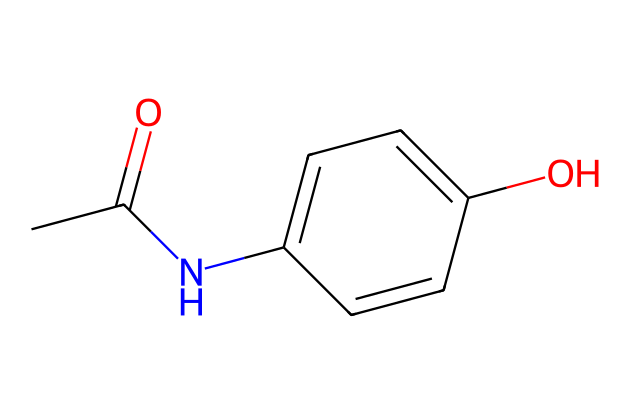What is the common name of this chemical? The SMILES representation corresponds to a chemical structure that is widely recognized as Acetaminophen, which is a commonly used analgesic and antipyretic medication.
Answer: Acetaminophen How many carbon atoms are present in this molecule? By analyzing the SMILES notation, we can count the 'C' characters. There are 8 carbon atoms in total in this structure.
Answer: 8 What functional group is indicated by the 'NC' in the structure? The 'NC' in the SMILES denotes the presence of an amide functional group, where nitrogen (N) is bonded to a carbon (C) atom. This signifies that the molecule contains an amide linkage, indicating it's a drug.
Answer: amide What type of reaction might lead to liver toxicity connected to this drug? Acetaminophen metabolism generates a reactive metabolite that can lead to hepatotoxicity through a process known as bioactivation, especially when taken in excess, contributing to liver damage.
Answer: bioactivation How many rings are there in this molecular structure? The structure contains one aromatic ring indicated by the presence of alternating double bonds around the C1-C6 carbon atoms, characteristic of phenolic compounds.
Answer: 1 What type of bond connects the acetyl group to the aromatic ring? The bond connecting the acetyl group (CC(=O)) to the aromatic ring is a carbon-nitrogen bond from the amide formation, which is a single bond between carbon and nitrogen indicating a covalent linkage.
Answer: single bond What is the primary therapeutic use of this compound? Acetaminophen is primarily used to relieve pain (analgesic) and reduce fever (antipyretic), making it a common medication for headaches, muscle aches, and other pain-related conditions.
Answer: pain relief 